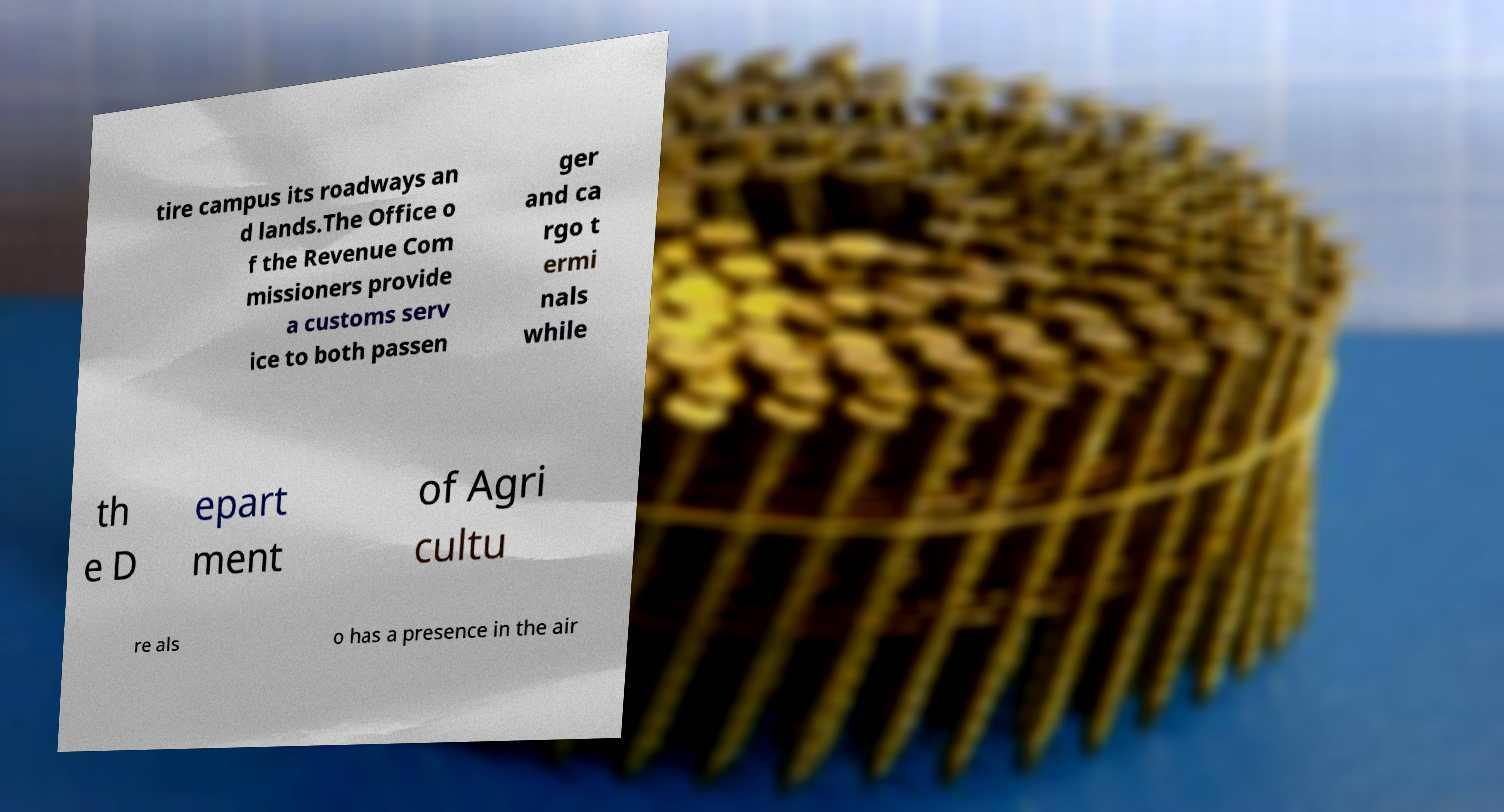Could you extract and type out the text from this image? tire campus its roadways an d lands.The Office o f the Revenue Com missioners provide a customs serv ice to both passen ger and ca rgo t ermi nals while th e D epart ment of Agri cultu re als o has a presence in the air 